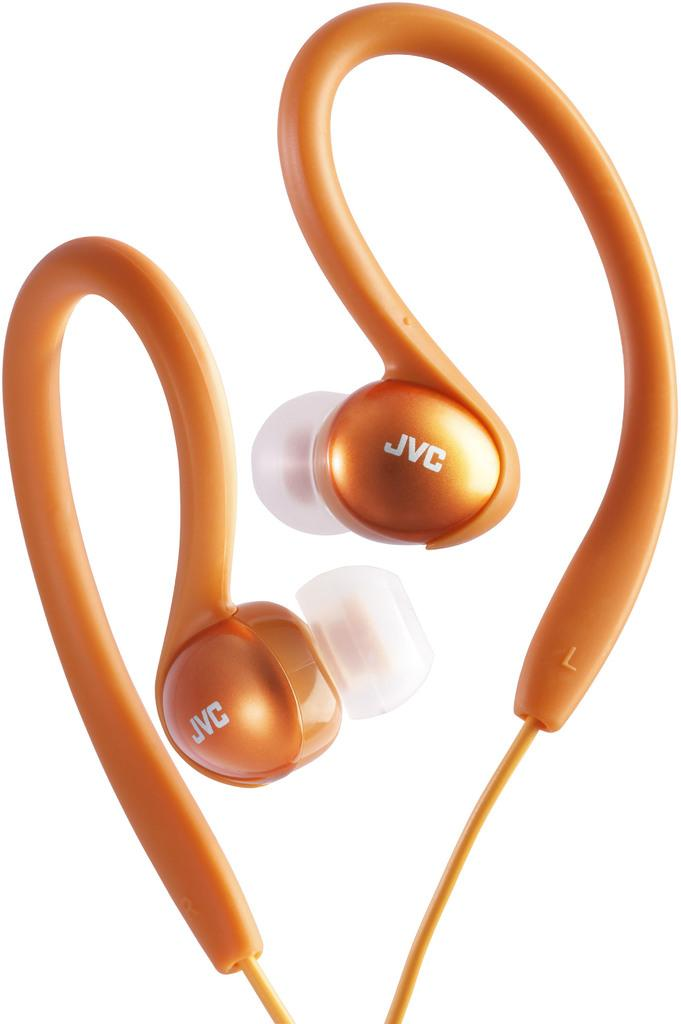<image>
Provide a brief description of the given image. Two orange colored earbuds from the maker JVC. 